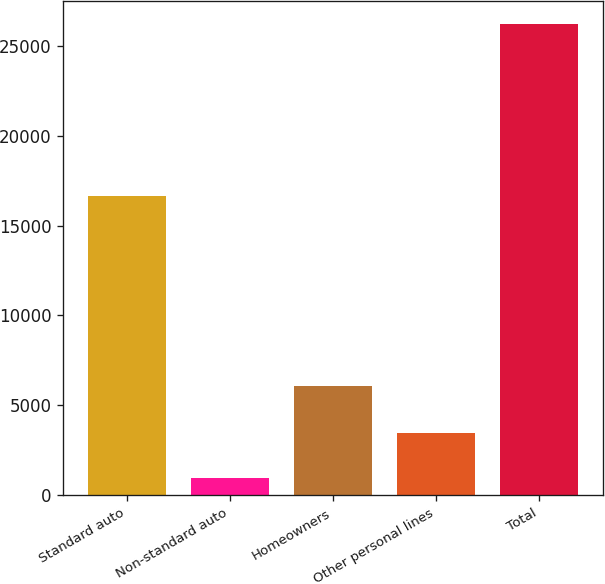<chart> <loc_0><loc_0><loc_500><loc_500><bar_chart><fcel>Standard auto<fcel>Non-standard auto<fcel>Homeowners<fcel>Other personal lines<fcel>Total<nl><fcel>16642<fcel>966<fcel>6077<fcel>3488.9<fcel>26195<nl></chart> 